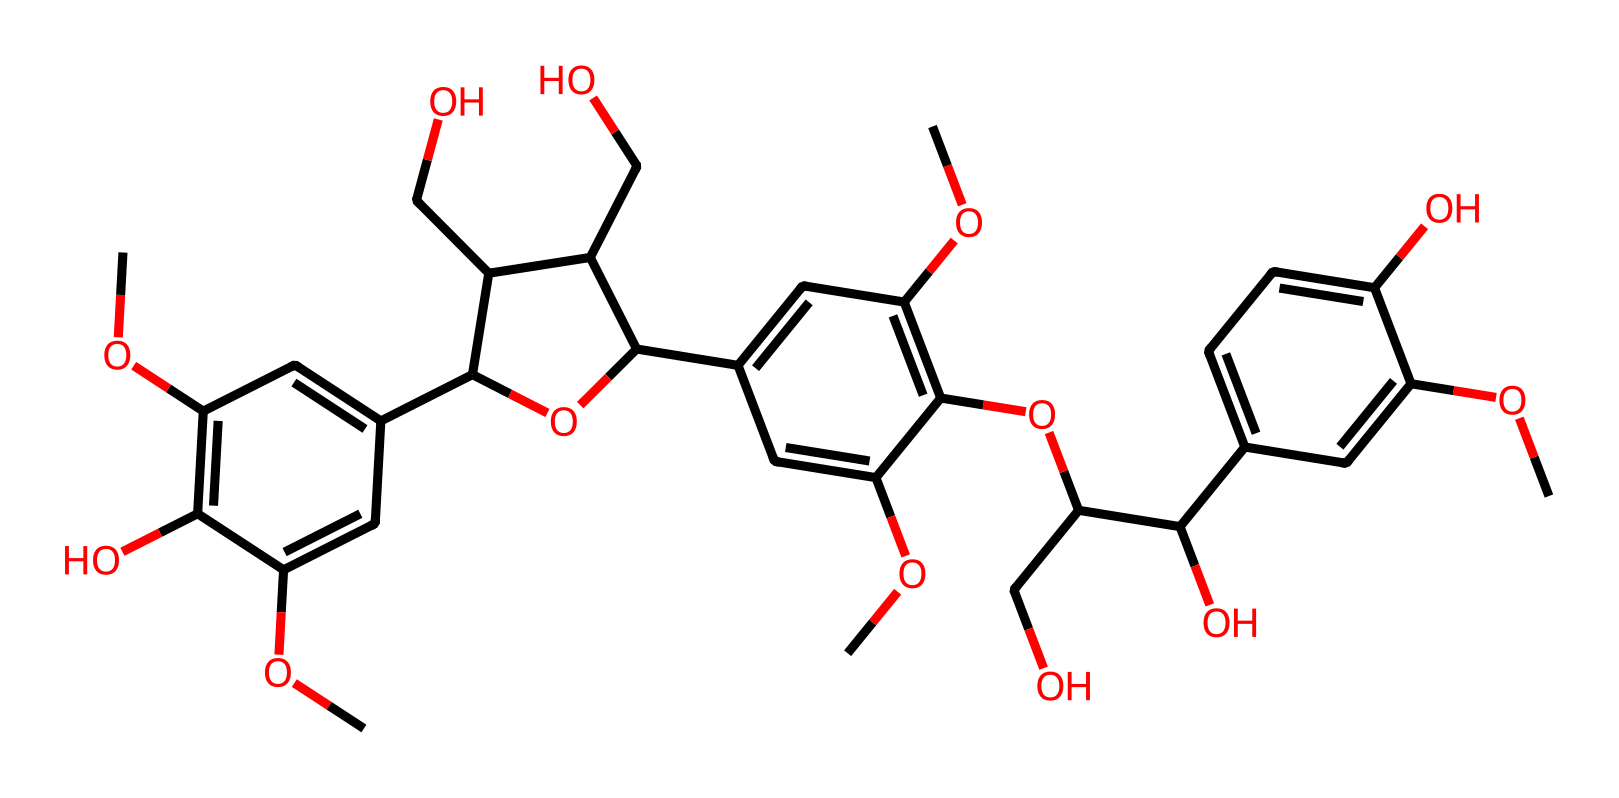What is the total number of carbon atoms in the structure? To determine the total number of carbon atoms, I count the 'C' symbols represented in the SMILES notation. Each 'C' indicates a carbon atom, leading to the total count. In this structure, there are 22 carbon atoms.
Answer: 22 How many hydroxyl (-OH) groups are present in this chemical? Hydroxyl groups are represented as 'O' in conjunction with hydrogen. By scanning the SMILES for occurrences of 'C(O)', we find that there are four such instances in the structure, indicating there are four hydroxyl groups.
Answer: 4 What type of functional groups are predominantly found in this carbohydrate structure? The predominant functional groups in carbohydrates include hydroxyl (-OH) groups and ether (R-O-R') linkages. In this case, the structure has multiple -OH groups and ether linkages that connect different parts of the molecule. Thus, the explanation highlights these dominant groups.
Answer: hydroxyl and ether Are there any rings present in the structure? To identify rings in the structure, I look for numbers that indicate a connection back to earlier parts of the chain in the SMILES. There are multiple occurrences of numbers like '2', '3', and '4' showing that there are several cyclic structures in the molecule. Therefore, there are rings present.
Answer: yes Which element is indicated as being part of the ether linkages in this structure? Ether linkages are formed when an oxygen atom connects two carbon groups (R-O-R'). In the SMILES notation, the 'O' indicates the presence of oxygen atoms that form these linkages. As I observe the representation, I can confirm that the oxygen is the element responsible for ether formation.
Answer: oxygen What does the presence of multiple ethereal rings suggest about the stability of this carbohydrate? The presence of multiple ether linkages can enhance the stability of the carbohydrate structure as they can impede hydrolysis and contribute to the rigidity of the molecule. This suggests that the complex structure is likely stable due to these features in its architecture.
Answer: stability 